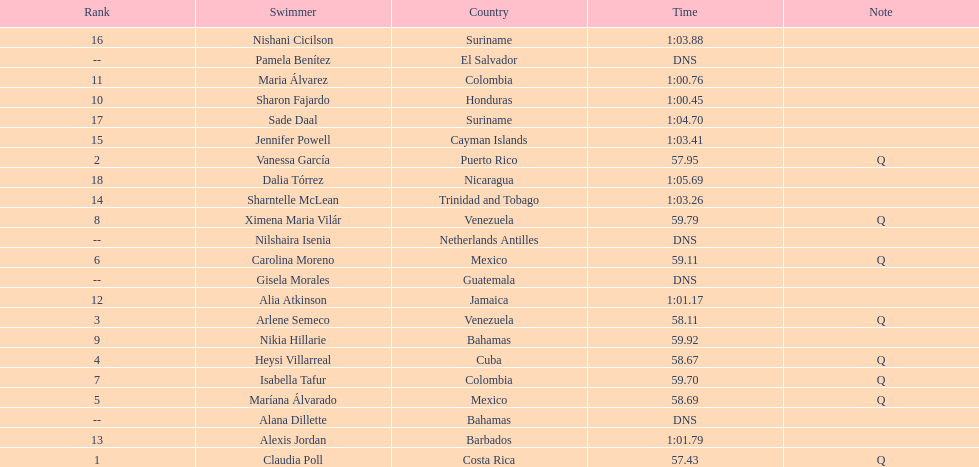How many competitors from venezuela qualified for the final? 2. 